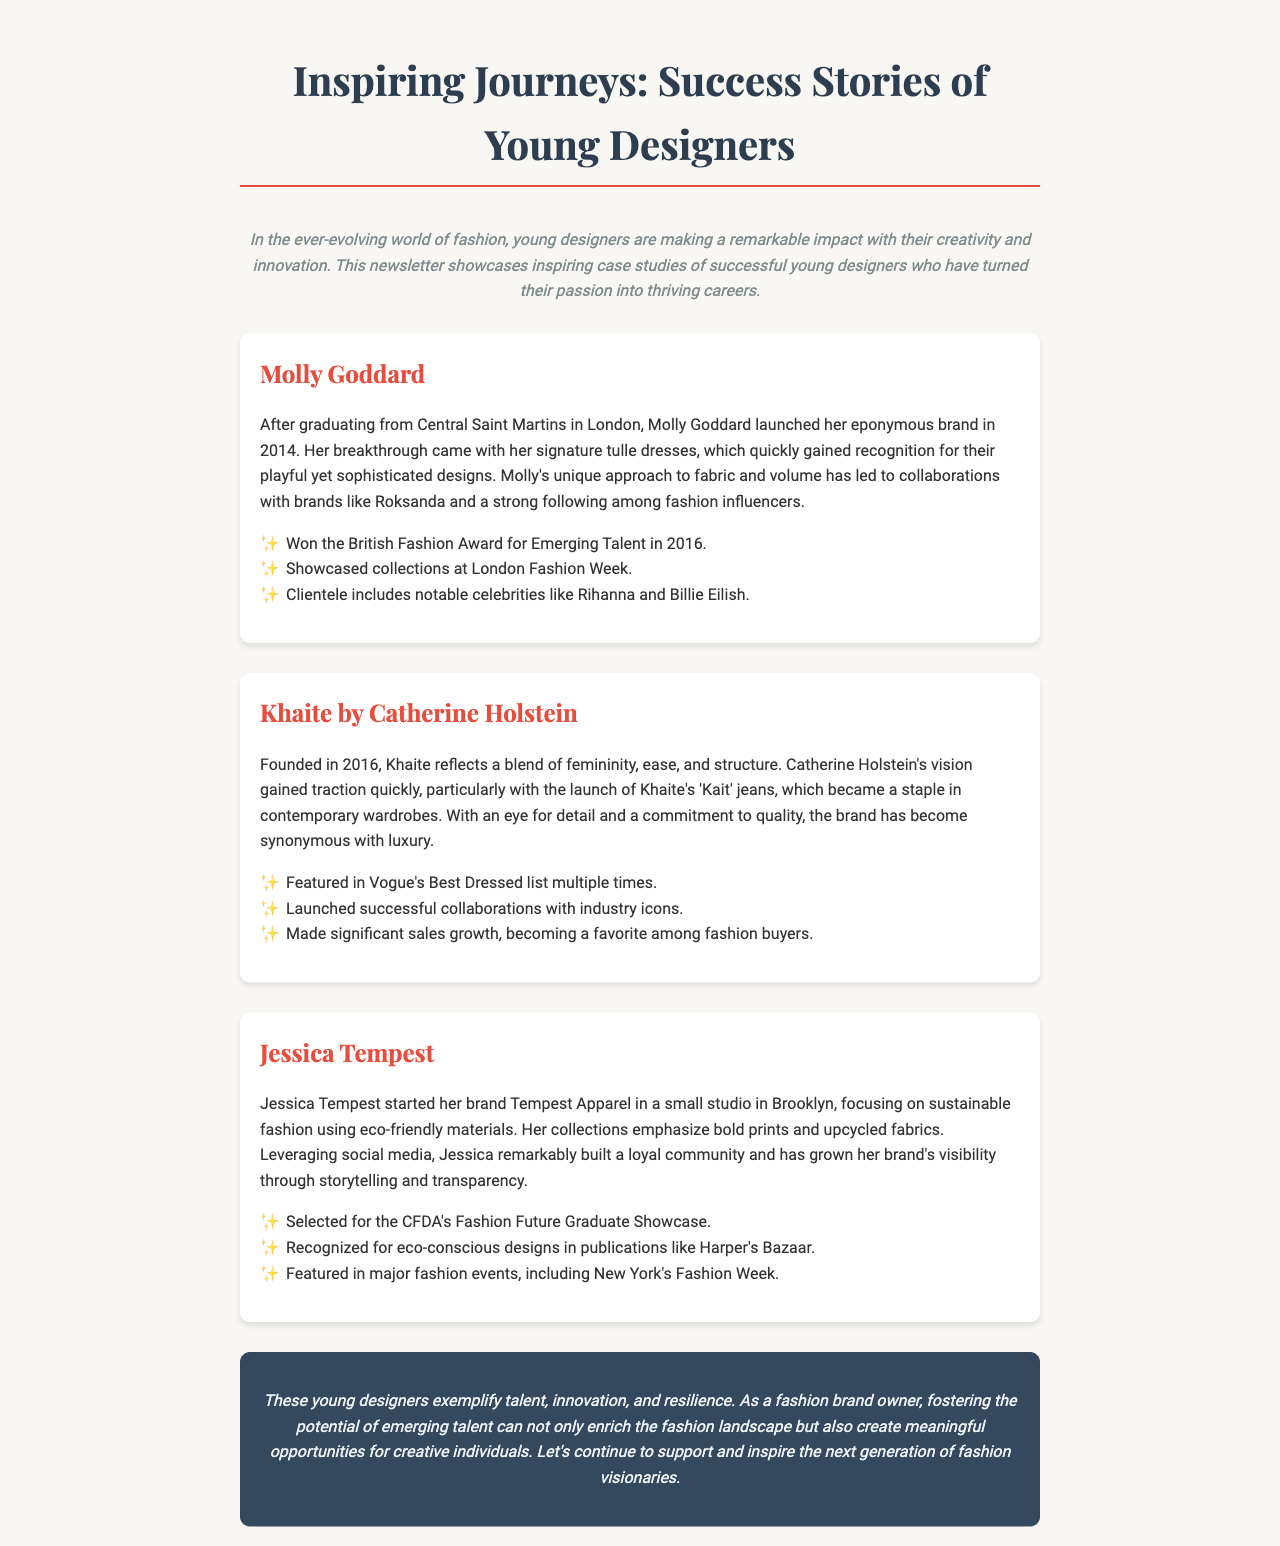What year did Molly Goddard launch her brand? The document states that Molly Goddard launched her eponymous brand in 2014.
Answer: 2014 Which award did Molly Goddard win in 2016? The newsletter mentions that she won the British Fashion Award for Emerging Talent in 2016.
Answer: British Fashion Award for Emerging Talent What is Khaite known for? The document highlights that Khaite is known for its 'Kait' jeans, which became a staple in contemporary wardrobes.
Answer: 'Kait' jeans What type of fashion does Jessica Tempest focus on? The case study specifies that Jessica Tempest focuses on sustainable fashion using eco-friendly materials.
Answer: Sustainable fashion How did Jessica Tempest grow her brand's visibility? According to the document, she grew her brand's visibility through storytelling and transparency via social media.
Answer: Storytelling and transparency What significant recognition did Jessica Tempest receive? The newsletter states that she was selected for the CFDA's Fashion Future Graduate Showcase, indicating her recognition in the industry.
Answer: CFDA's Fashion Future Graduate Showcase How many designers are featured in the newsletter? The document showcases three successful young designers in the case studies section.
Answer: Three What is the overall theme of the newsletter? The introduction conveys that the newsletter showcases inspiring case studies of successful young designers who have turned their passion into thriving careers.
Answer: Inspiring case studies of young designers 